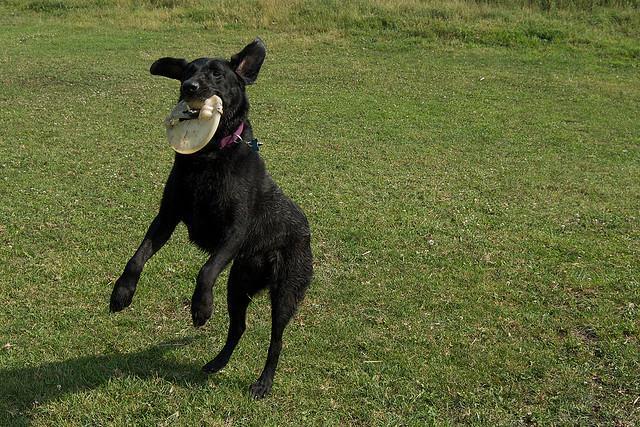How many dogs are in the photo?
Give a very brief answer. 1. How many horses are in the photograph?
Give a very brief answer. 0. 